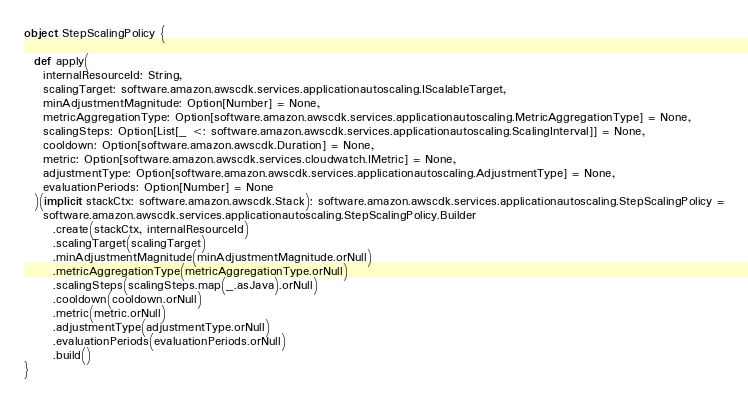Convert code to text. <code><loc_0><loc_0><loc_500><loc_500><_Scala_>object StepScalingPolicy {

  def apply(
    internalResourceId: String,
    scalingTarget: software.amazon.awscdk.services.applicationautoscaling.IScalableTarget,
    minAdjustmentMagnitude: Option[Number] = None,
    metricAggregationType: Option[software.amazon.awscdk.services.applicationautoscaling.MetricAggregationType] = None,
    scalingSteps: Option[List[_ <: software.amazon.awscdk.services.applicationautoscaling.ScalingInterval]] = None,
    cooldown: Option[software.amazon.awscdk.Duration] = None,
    metric: Option[software.amazon.awscdk.services.cloudwatch.IMetric] = None,
    adjustmentType: Option[software.amazon.awscdk.services.applicationautoscaling.AdjustmentType] = None,
    evaluationPeriods: Option[Number] = None
  )(implicit stackCtx: software.amazon.awscdk.Stack): software.amazon.awscdk.services.applicationautoscaling.StepScalingPolicy =
    software.amazon.awscdk.services.applicationautoscaling.StepScalingPolicy.Builder
      .create(stackCtx, internalResourceId)
      .scalingTarget(scalingTarget)
      .minAdjustmentMagnitude(minAdjustmentMagnitude.orNull)
      .metricAggregationType(metricAggregationType.orNull)
      .scalingSteps(scalingSteps.map(_.asJava).orNull)
      .cooldown(cooldown.orNull)
      .metric(metric.orNull)
      .adjustmentType(adjustmentType.orNull)
      .evaluationPeriods(evaluationPeriods.orNull)
      .build()
}
</code> 